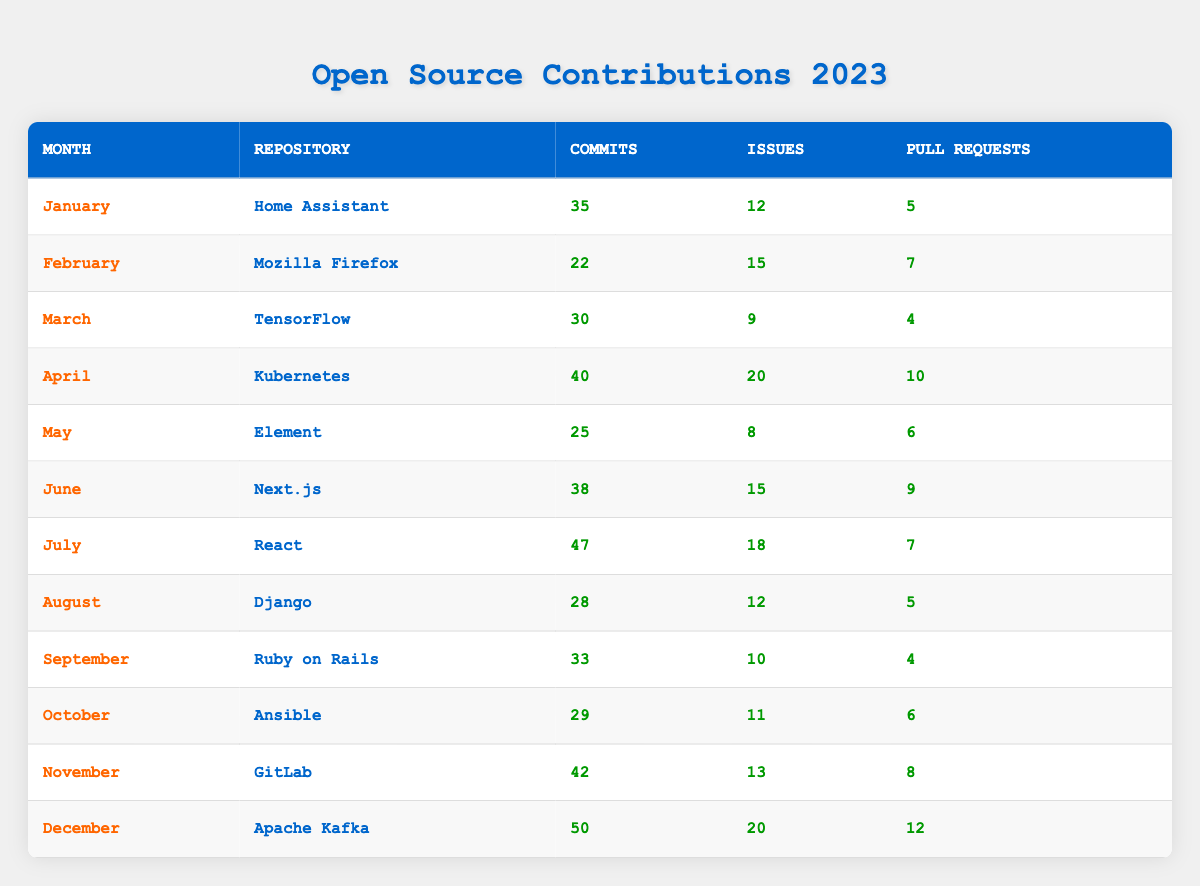What were the total contributions (commits, issues, and pull requests) for Django in 2023? For Django in August, the table shows 28 commits, 12 issues, and 5 pull requests. Adding these gives a total of 28 + 12 + 5 = 45 contributions.
Answer: 45 Which month had the highest number of commits? By examining the commits column, December has the highest value at 50 commits for Apache Kafka.
Answer: December How many more pull requests were made in November compared to March? In November, there were 8 pull requests for GitLab, while in March, there were 4 pull requests for TensorFlow. The difference is 8 - 4 = 4 pull requests.
Answer: 4 Did any month have more issues than commits? Looking through the table, in February, there were 15 issues for Mozilla Firefox and 22 commits, hence there were no months where issues exceeded commits.
Answer: No What was the average number of commits made during the first half of the year (January to June)? The number of commits for the first half of the year is as follows: 35 (Jan) + 22 (Feb) + 30 (Mar) + 40 (Apr) + 25 (May) + 38 (Jun) = 190. There are 6 months, so the average is 190 / 6 = 31.67.
Answer: 31.67 Which repository had the lowest number of pull requests in the second half of the year? Analyzing the pull requests for the second half: July (7), August (5), September (4), October (6), November (8), December (12). The lowest is 4 in September for Ruby on Rails.
Answer: Ruby on Rails What month showed an increase in both commits and pull requests compared to the previous month? Comparing consecutive months, June increased both commits (38 from 25) and pull requests (9 from 6) compared to May. Thus, June is the month meeting this condition.
Answer: June Which repository had the most total contributions for the entire year? Summing for each repository: Home Assistant (52), Mozilla Firefox (44), TensorFlow (43), Kubernetes (70), Element (39), Next.js (62), React (72), Django (45), Ruby on Rails (47), Ansible (46), GitLab (63), Apache Kafka (82). The most total contributions were for Apache Kafka with 82.
Answer: Apache Kafka 